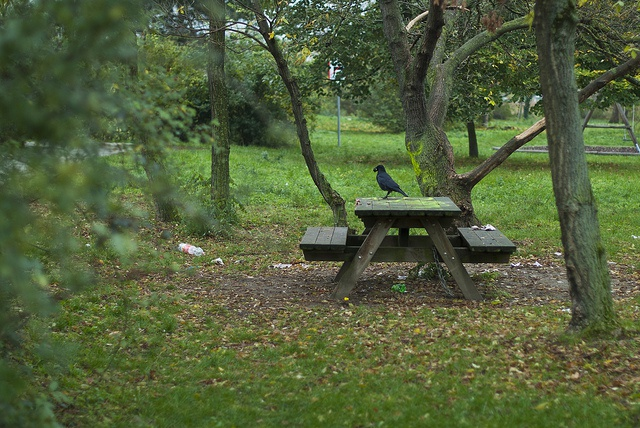Describe the objects in this image and their specific colors. I can see bench in darkgreen, black, gray, and darkgray tones, bird in darkgreen, black, navy, blue, and teal tones, and bottle in darkgreen, lightgray, darkgray, and lightpink tones in this image. 